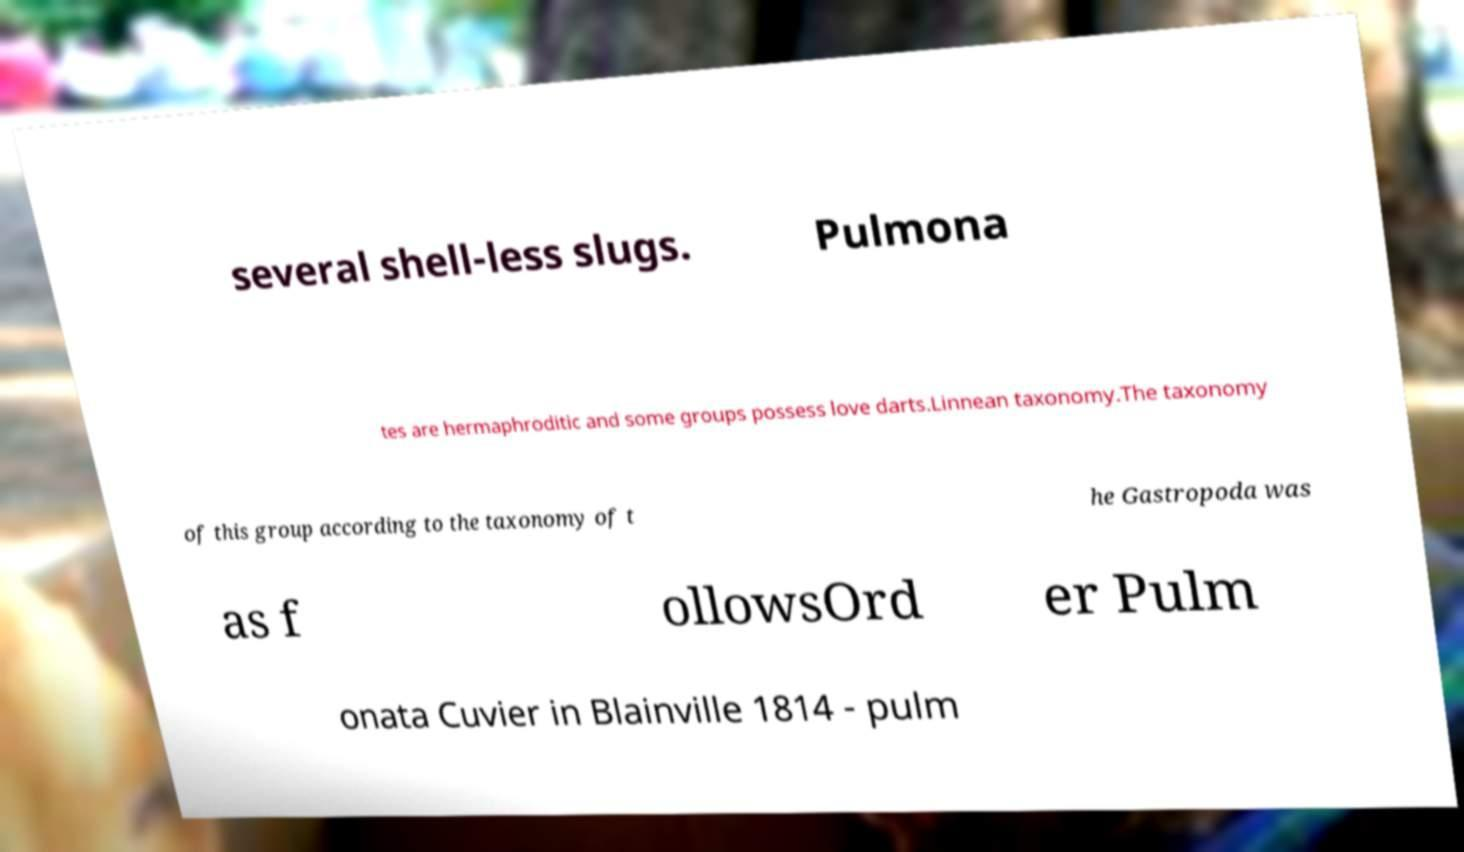There's text embedded in this image that I need extracted. Can you transcribe it verbatim? several shell-less slugs. Pulmona tes are hermaphroditic and some groups possess love darts.Linnean taxonomy.The taxonomy of this group according to the taxonomy of t he Gastropoda was as f ollowsOrd er Pulm onata Cuvier in Blainville 1814 - pulm 